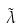<formula> <loc_0><loc_0><loc_500><loc_500>\tilde { \lambda }</formula> 